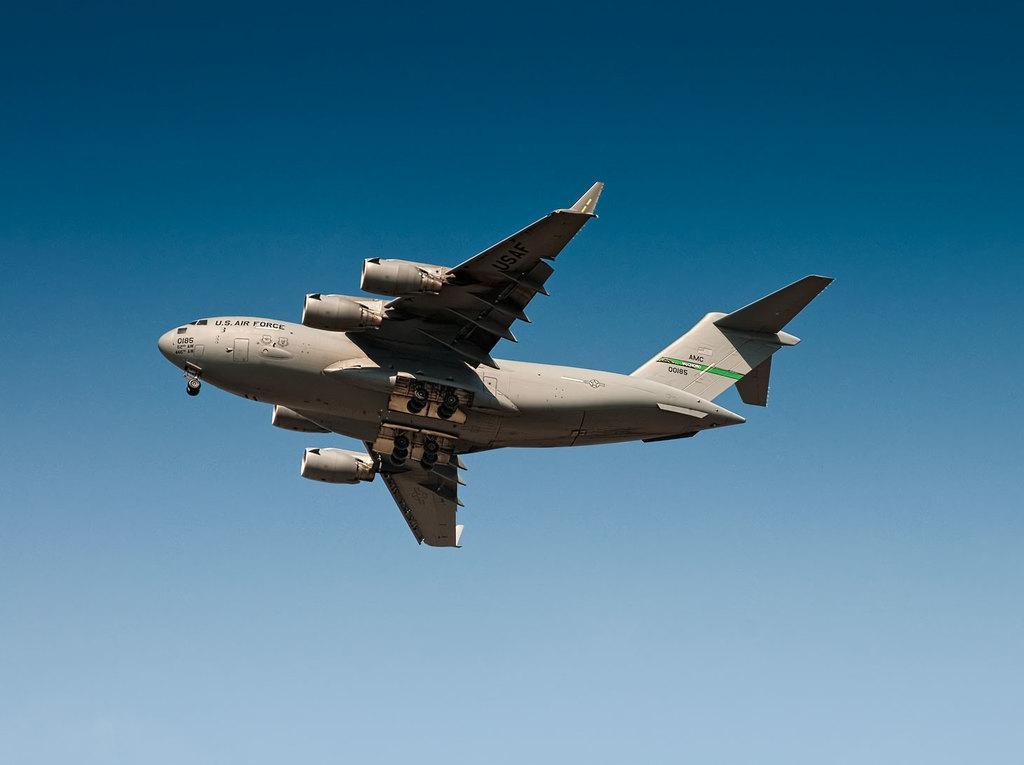Describe this image in one or two sentences. In this image I can see a flight visible in the air I can see the sky. 